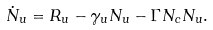Convert formula to latex. <formula><loc_0><loc_0><loc_500><loc_500>\dot { N } _ { u } = R _ { u } - \gamma _ { u } N _ { u } - \Gamma N _ { c } N _ { u } .</formula> 